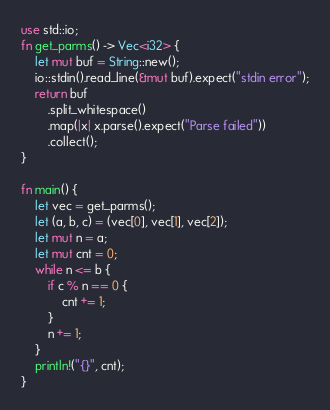<code> <loc_0><loc_0><loc_500><loc_500><_Rust_>use std::io;
fn get_parms() -> Vec<i32> {
    let mut buf = String::new();
    io::stdin().read_line(&mut buf).expect("stdin error");
    return buf
        .split_whitespace()
        .map(|x| x.parse().expect("Parse failed"))
        .collect();
}

fn main() {
    let vec = get_parms();
    let (a, b, c) = (vec[0], vec[1], vec[2]);
    let mut n = a;
    let mut cnt = 0;
    while n <= b {
        if c % n == 0 {
            cnt += 1;
        }
        n += 1;
    }
    println!("{}", cnt);
}

</code> 